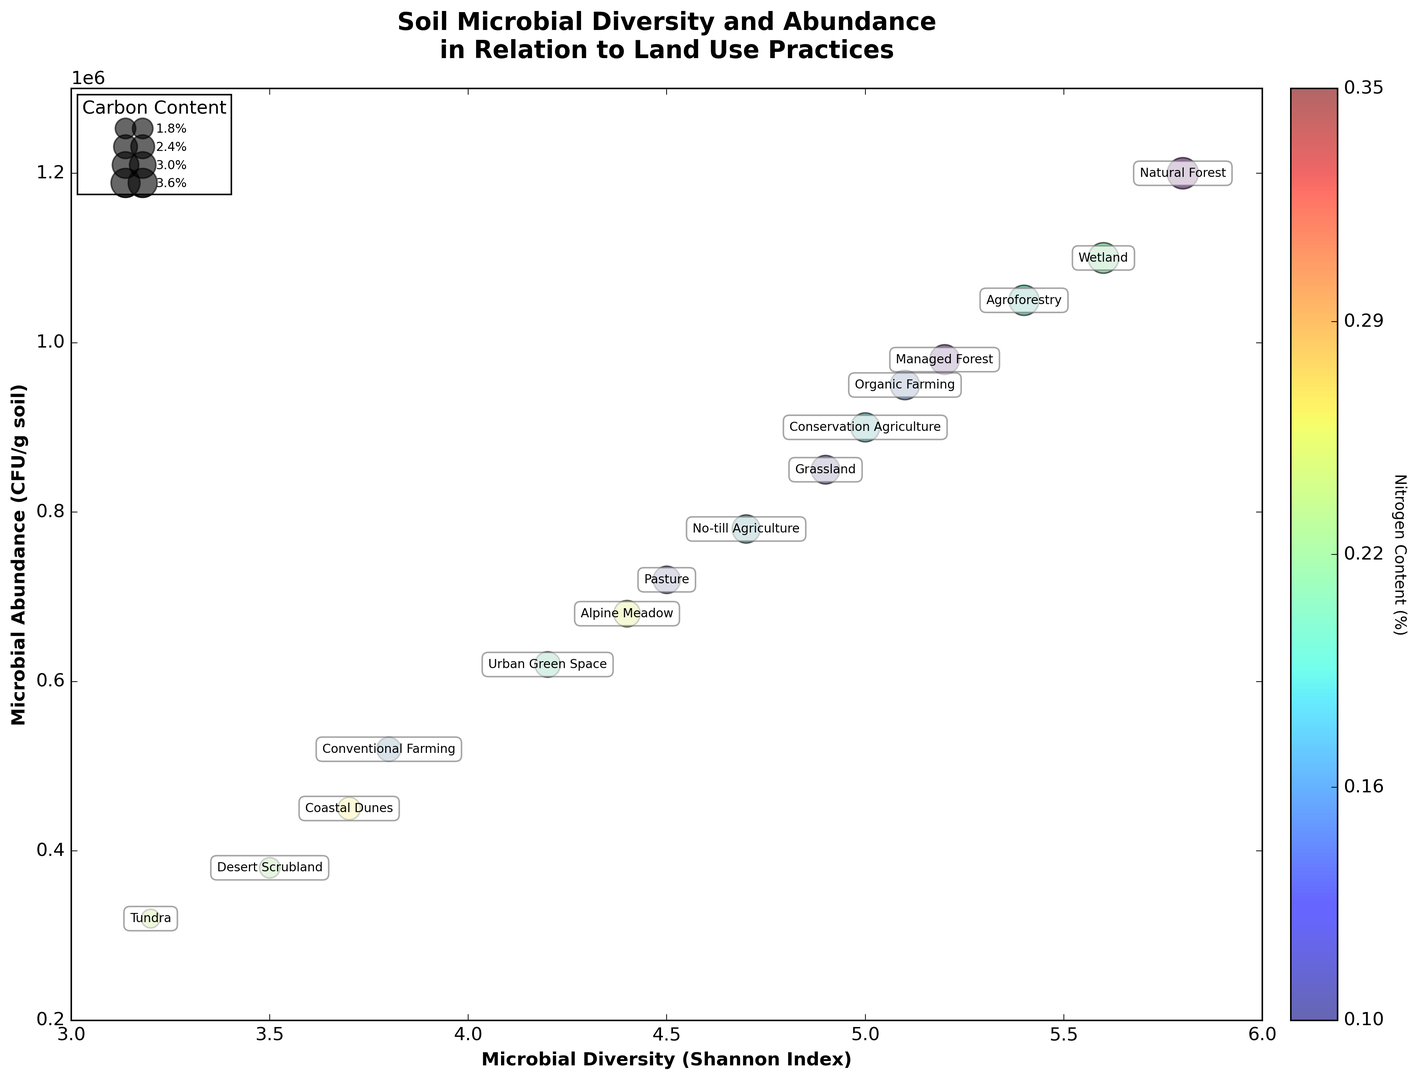What land use practice shows the highest microbial diversity? Look at the horizontal axis labeled 'Microbial Diversity (Shannon Index)' and identify the point with the highest value. Natural Forest has the highest Shannon Index at 5.8.
Answer: Natural Forest Which land use practice has the lowest microbial abundance? Look at the vertical axis labeled 'Microbial Abundance (CFU/g soil)' and find the point with the lowest value. Tundra has the lowest microbial abundance at 320,000 CFU/g soil.
Answer: Tundra Which land use has a higher microbial diversity: Organic Farming or Conventional Farming? Compare the values on the horizontal axis for Organic Farming and Conventional Farming. Organic Farming has a Shannon Index of 5.1, which is higher than Conventional Farming's 3.8.
Answer: Organic Farming What is the carbon content of the land use with the highest microbial abundance? Identify the highest point on the vertical axis and look at the size of the bubble, representing carbon content, or refer to the legend. Natural Forest, with the highest microbial abundance, has a Carbon Content of 4.2%.
Answer: 4.2% How does the nitrogen content vary between Agroforestry and Coastal Dunes? Examine the colors of the bubbles for Agroforestry and Coastal Dunes in the color bar legend. Agroforestry has a higher nitrogen content closer to 0.32%, whereas Coastal Dunes have a lower nitrogen content closer to 0.15%.
Answer: Agroforestry has higher nitrogen content Which land use shows a combination of moderate microbial diversity and high carbon content? Look for bubbles with moderate horizontal positions (around 4-5) and larger sizes. Grassland has a microbial diversity of 4.9 and a carbon content of 3.5%.
Answer: Grassland Are there any land uses with both low microbial diversity and low carbon content? Identify bubbles on the far left (low on horizontal axis) and small in size (low carbon content). Desert Scrubland and Tundra both have low microbial diversity (3.5 and 3.2, respectively) and low carbon content (1.8% and 1.5%, respectively).
Answer: Desert Scrubland and Tundra What is the relationship between carbon content and microbial diversity? Observe the size of bubbles across the horizontal axis. Larger bubbles (higher carbon content) tend to be positioned further right, indicating higher microbial diversity.
Answer: Higher carbon content tends to correlate with higher microbial diversity 